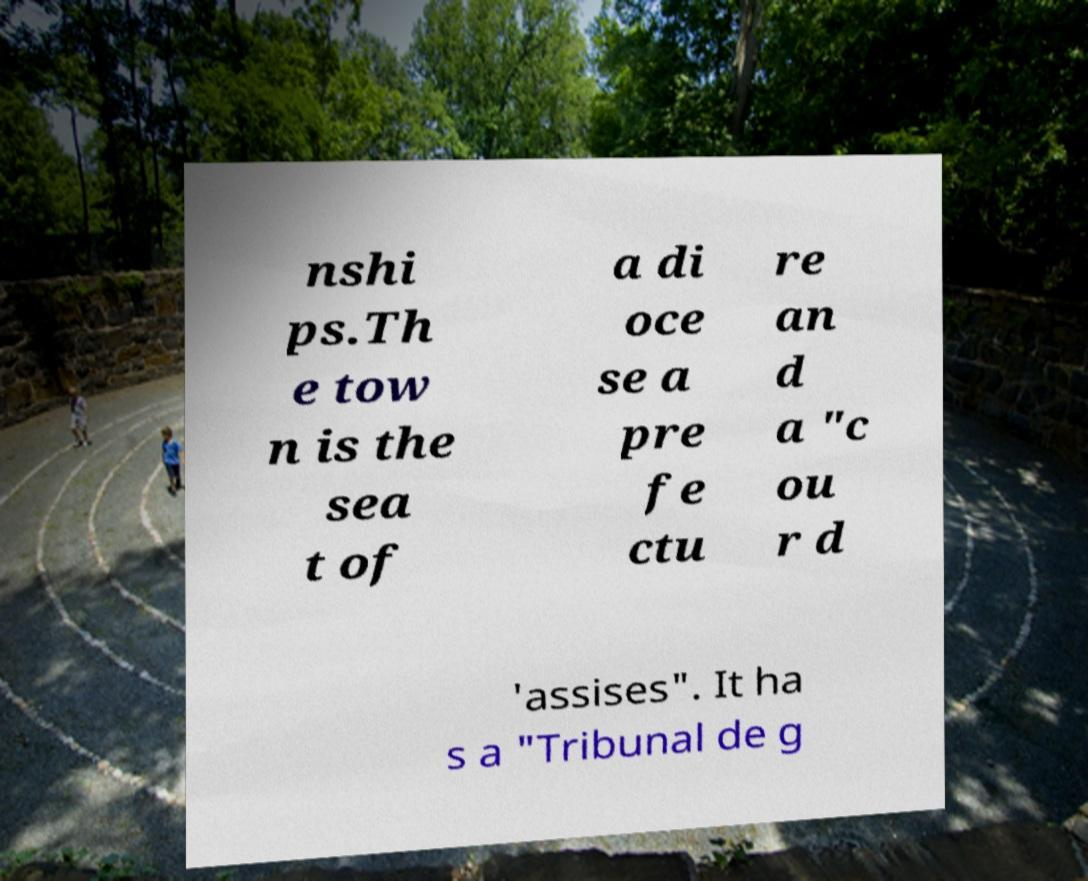Please read and relay the text visible in this image. What does it say? nshi ps.Th e tow n is the sea t of a di oce se a pre fe ctu re an d a "c ou r d 'assises". It ha s a "Tribunal de g 